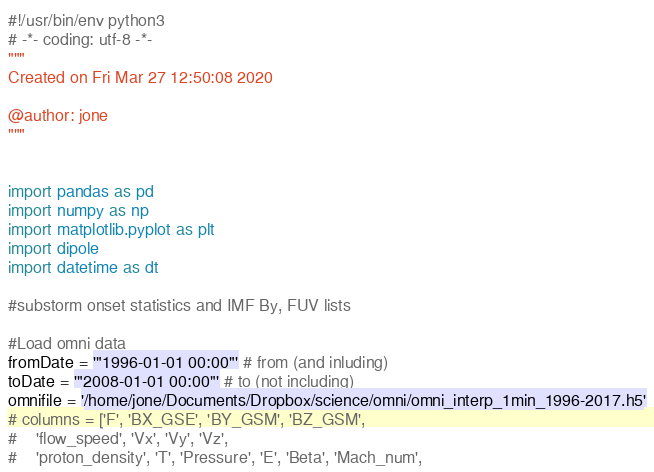<code> <loc_0><loc_0><loc_500><loc_500><_Python_>#!/usr/bin/env python3
# -*- coding: utf-8 -*-
"""
Created on Fri Mar 27 12:50:08 2020

@author: jone
"""


import pandas as pd
import numpy as np
import matplotlib.pyplot as plt
import dipole
import datetime as dt

#substorm onset statistics and IMF By, FUV lists

#Load omni data
fromDate = '"1996-01-01 00:00"' # from (and inluding)
toDate = '"2008-01-01 00:00"' # to (not including)
omnifile = '/home/jone/Documents/Dropbox/science/omni/omni_interp_1min_1996-2017.h5'
# columns = ['F', 'BX_GSE', 'BY_GSM', 'BZ_GSM',
#    'flow_speed', 'Vx', 'Vy', 'Vz',
#    'proton_density', 'T', 'Pressure', 'E', 'Beta', 'Mach_num',</code> 